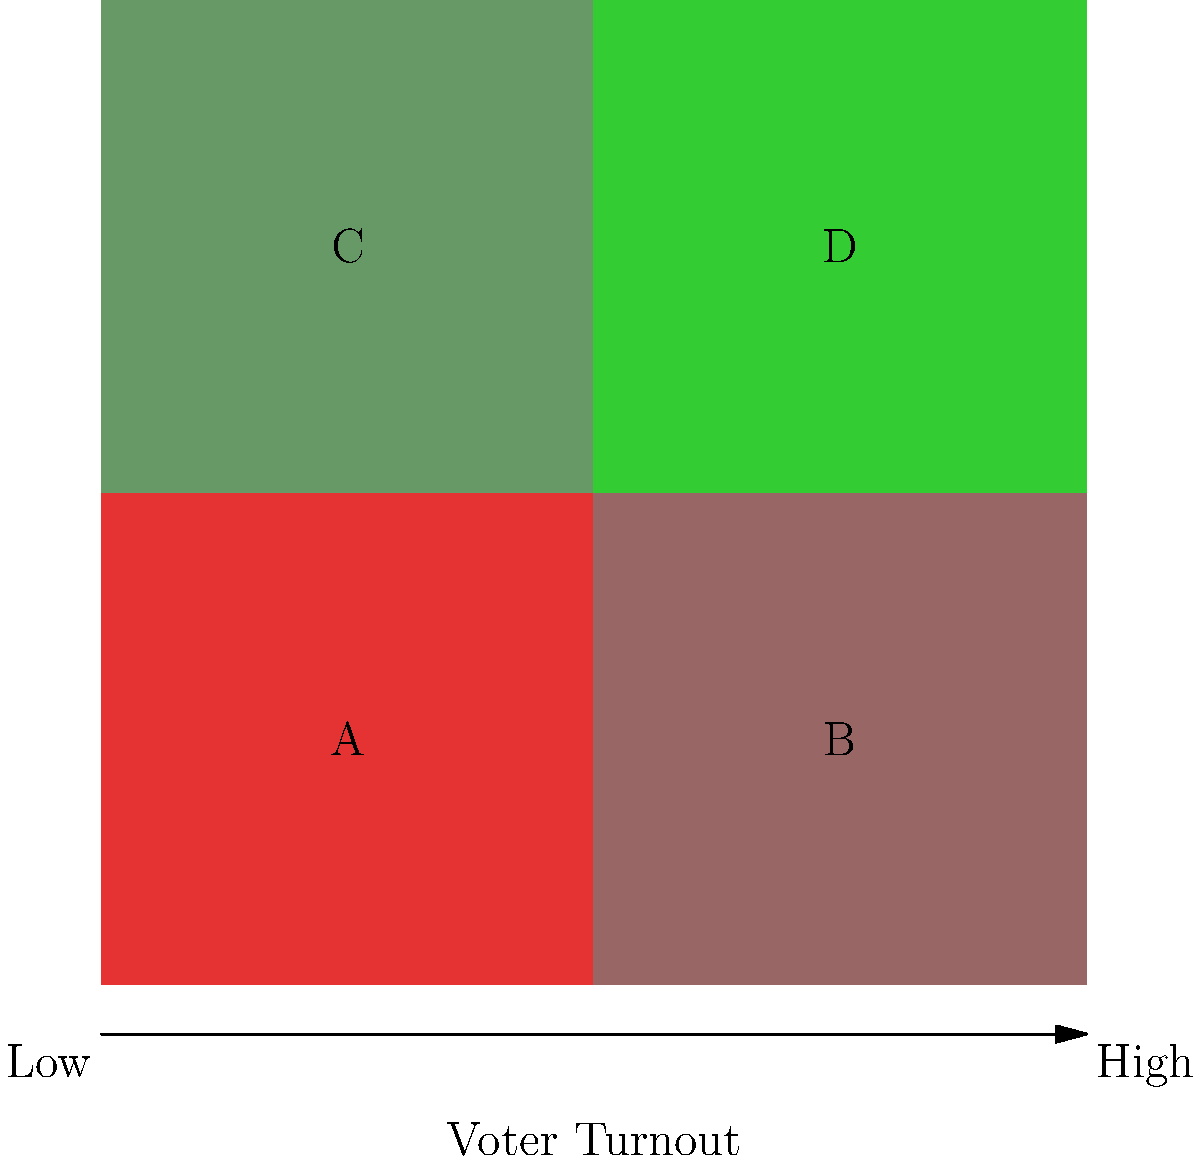The map shows voter turnout across four regions (A, B, C, and D) of a country, with darker green indicating higher turnout. If you were to implement a policy to increase overall voter participation, which region should be prioritized, and why? To determine which region should be prioritized for increasing overall voter participation, we need to analyze the color-coded map:

1. Interpret the color scheme:
   - Darker green indicates higher voter turnout
   - Lighter colors (red to light green) indicate lower voter turnout

2. Analyze each region:
   - Region A (bottom-left): Red color, indicating the lowest voter turnout
   - Region B (bottom-right): Light red, indicating low voter turnout
   - Region C (top-left): Light green, indicating moderate voter turnout
   - Region D (top-right): Dark green, indicating the highest voter turnout

3. Identify the region with the lowest turnout:
   Region A has the lowest voter turnout, as indicated by the red color.

4. Consider the potential impact:
   Focusing efforts on the region with the lowest turnout (Region A) has the highest potential for increasing overall voter participation, as it has the most room for improvement.

5. Strategic considerations:
   - Targeting Region A could help understand and address the factors contributing to low turnout
   - Improvements in Region A could have a significant effect on the overall national voter turnout statistics
   - Addressing issues in the lowest-performing region may provide insights applicable to other low-turnout areas (e.g., Region B)

Therefore, prioritizing Region A for implementing policies to increase voter participation would likely yield the most significant improvement in overall voter turnout.
Answer: Region A 